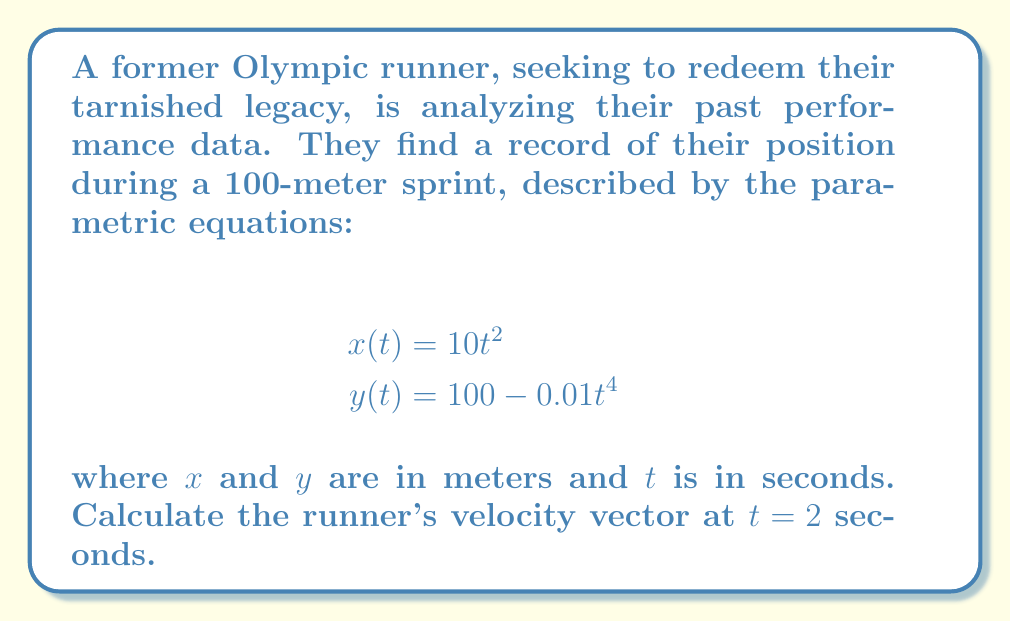Provide a solution to this math problem. To find the velocity vector, we need to differentiate the position vector with respect to time. The position vector is given by:

$$\mathbf{r}(t) = \langle x(t), y(t) \rangle = \langle 10t^2, 100 - 0.01t^4 \rangle$$

The velocity vector is the derivative of the position vector:

$$\mathbf{v}(t) = \frac{d\mathbf{r}}{dt} = \langle \frac{dx}{dt}, \frac{dy}{dt} \rangle$$

Let's calculate each component:

1) For $x$-component:
   $$\frac{dx}{dt} = \frac{d}{dt}(10t^2) = 20t$$

2) For $y$-component:
   $$\frac{dy}{dt} = \frac{d}{dt}(100 - 0.01t^4) = -0.04t^3$$

Therefore, the velocity vector is:

$$\mathbf{v}(t) = \langle 20t, -0.04t^3 \rangle$$

At $t = 2$ seconds:

$$\mathbf{v}(2) = \langle 20(2), -0.04(2^3) \rangle = \langle 40, -0.32 \rangle$$
Answer: $\langle 40, -0.32 \rangle$ m/s 